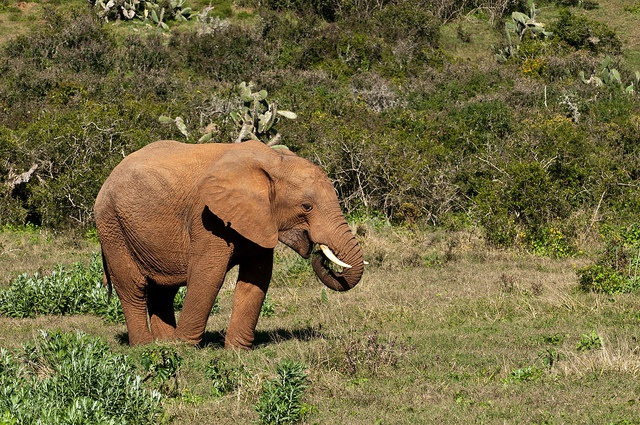Describe the objects in this image and their specific colors. I can see a elephant in darkgreen, gray, tan, black, and brown tones in this image. 